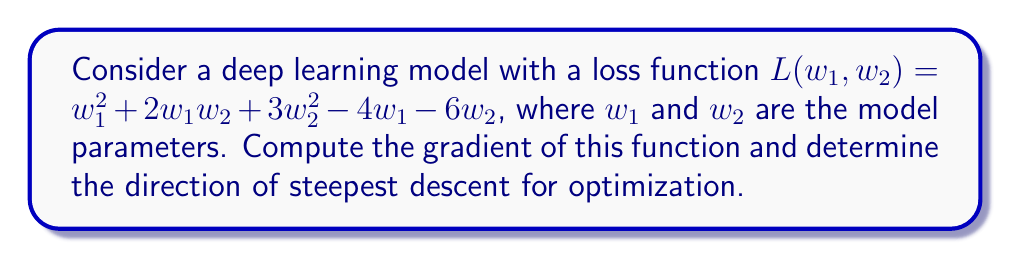Help me with this question. To solve this problem, we'll follow these steps:

1) The gradient of a multivariable function is a vector of partial derivatives with respect to each variable. For our function $L(w_1, w_2)$, we need to compute:

   $$\nabla L = \left(\frac{\partial L}{\partial w_1}, \frac{\partial L}{\partial w_2}\right)$$

2) Let's compute each partial derivative:

   For $\frac{\partial L}{\partial w_1}$:
   $$\frac{\partial L}{\partial w_1} = 2w_1 + 2w_2 - 4$$

   For $\frac{\partial L}{\partial w_2}$:
   $$\frac{\partial L}{\partial w_2} = 2w_1 + 6w_2 - 6$$

3) Now we can write the gradient:

   $$\nabla L = (2w_1 + 2w_2 - 4, 2w_1 + 6w_2 - 6)$$

4) The direction of steepest descent is the negative of the gradient. So, the direction of steepest descent is:

   $$-\nabla L = -(2w_1 + 2w_2 - 4, 2w_1 + 6w_2 - 6)$$

This result is particularly relevant for optimization in deep learning, as gradient descent algorithms use this direction to update model parameters and minimize the loss function.
Answer: $\nabla L = (2w_1 + 2w_2 - 4, 2w_1 + 6w_2 - 6)$
Direction of steepest descent: $-(2w_1 + 2w_2 - 4, 2w_1 + 6w_2 - 6)$ 